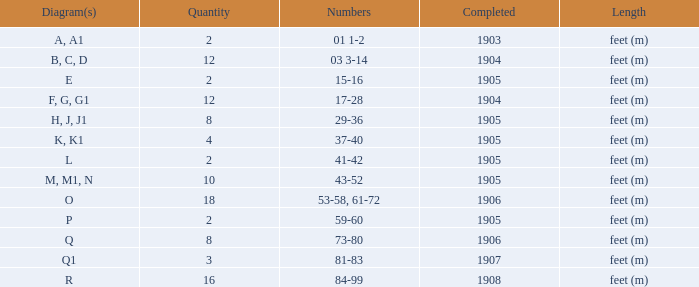What are the figures pertaining to the item accomplished prior to 1904? 01 1-2. 